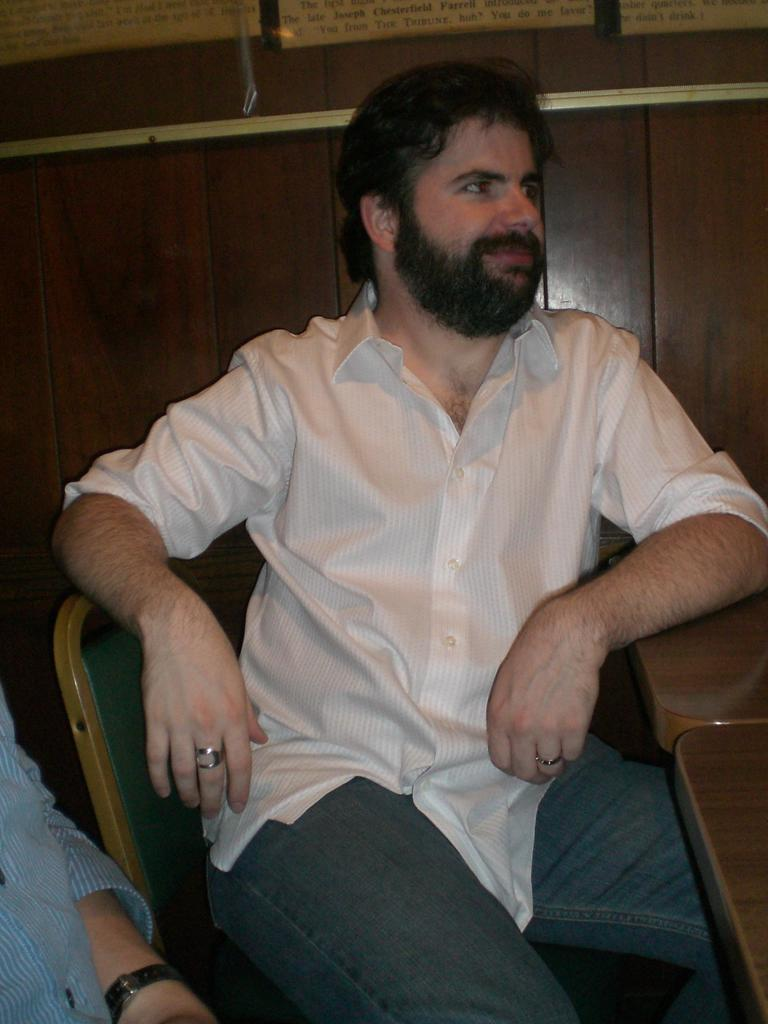What is the main subject of the image? There is a man in the image. What is the man wearing? The man is wearing a white shirt. What is the man doing in the image? The man is sitting on a chair. What can be observed about the man's facial hair? The man has a full beard on his face. What is the man's facial expression? The man is slightly smiling. What can be seen in the background of the image? There is a wooden wall in the background of the image. How many tramps are visible in the image? There are no tramps present in the image; it features a man sitting on a chair. What type of trains can be seen passing by in the image? There are no trains visible in the image. 